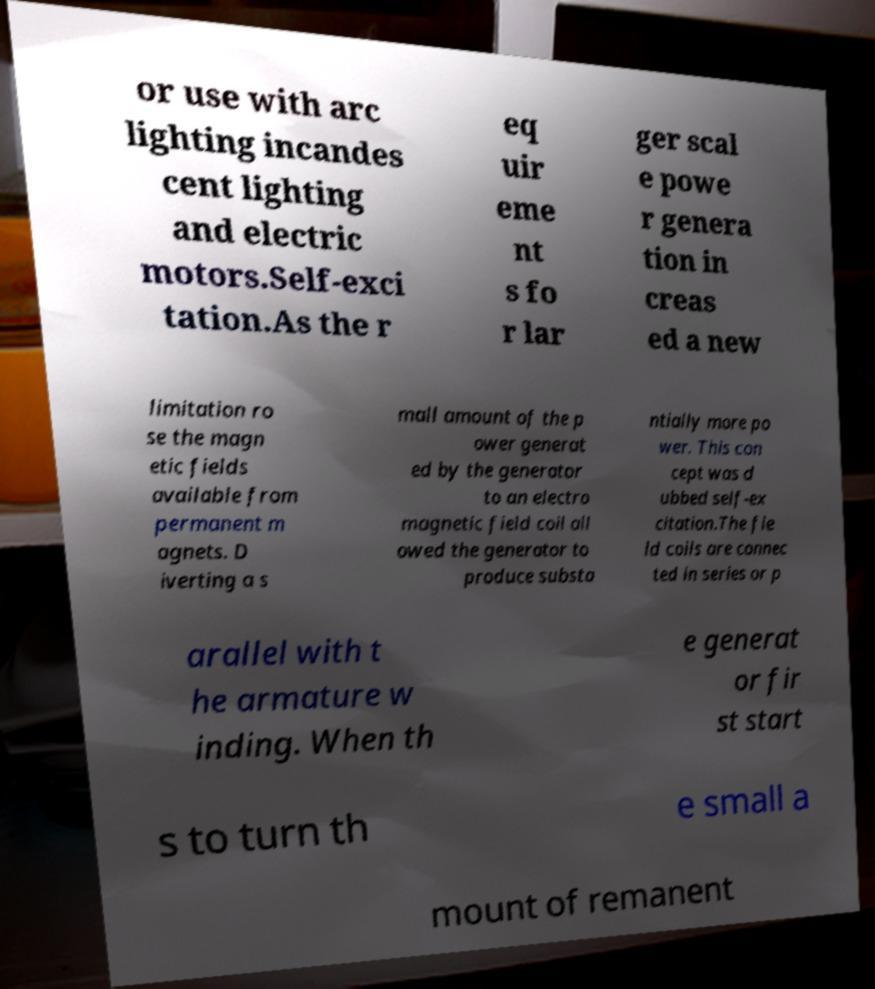Can you read and provide the text displayed in the image?This photo seems to have some interesting text. Can you extract and type it out for me? or use with arc lighting incandes cent lighting and electric motors.Self-exci tation.As the r eq uir eme nt s fo r lar ger scal e powe r genera tion in creas ed a new limitation ro se the magn etic fields available from permanent m agnets. D iverting a s mall amount of the p ower generat ed by the generator to an electro magnetic field coil all owed the generator to produce substa ntially more po wer. This con cept was d ubbed self-ex citation.The fie ld coils are connec ted in series or p arallel with t he armature w inding. When th e generat or fir st start s to turn th e small a mount of remanent 